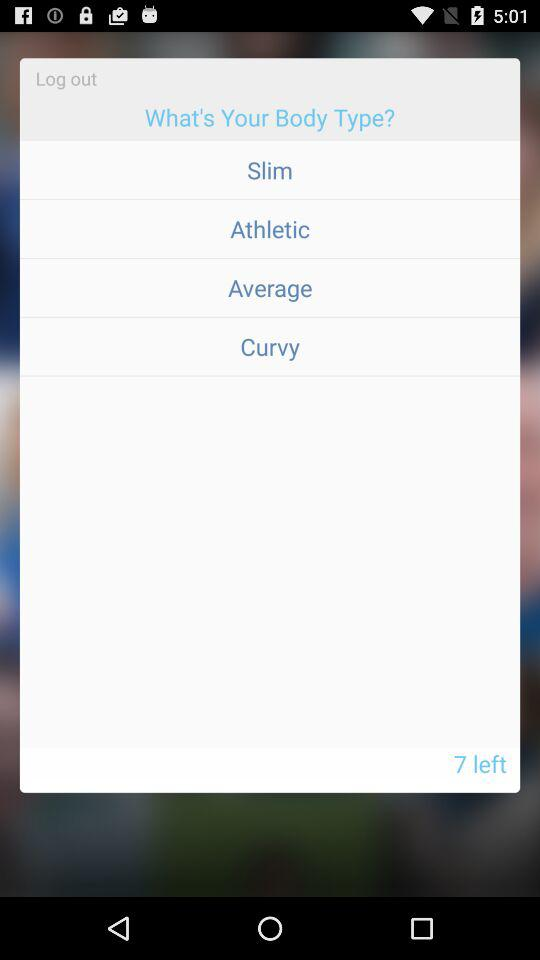How many body types are there to choose from?
Answer the question using a single word or phrase. 4 